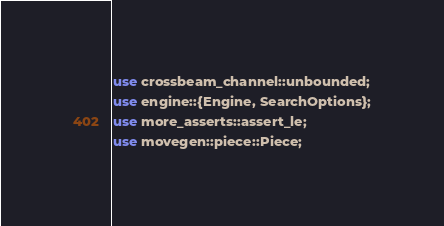Convert code to text. <code><loc_0><loc_0><loc_500><loc_500><_Rust_>use crossbeam_channel::unbounded;
use engine::{Engine, SearchOptions};
use more_asserts::assert_le;
use movegen::piece::Piece;</code> 